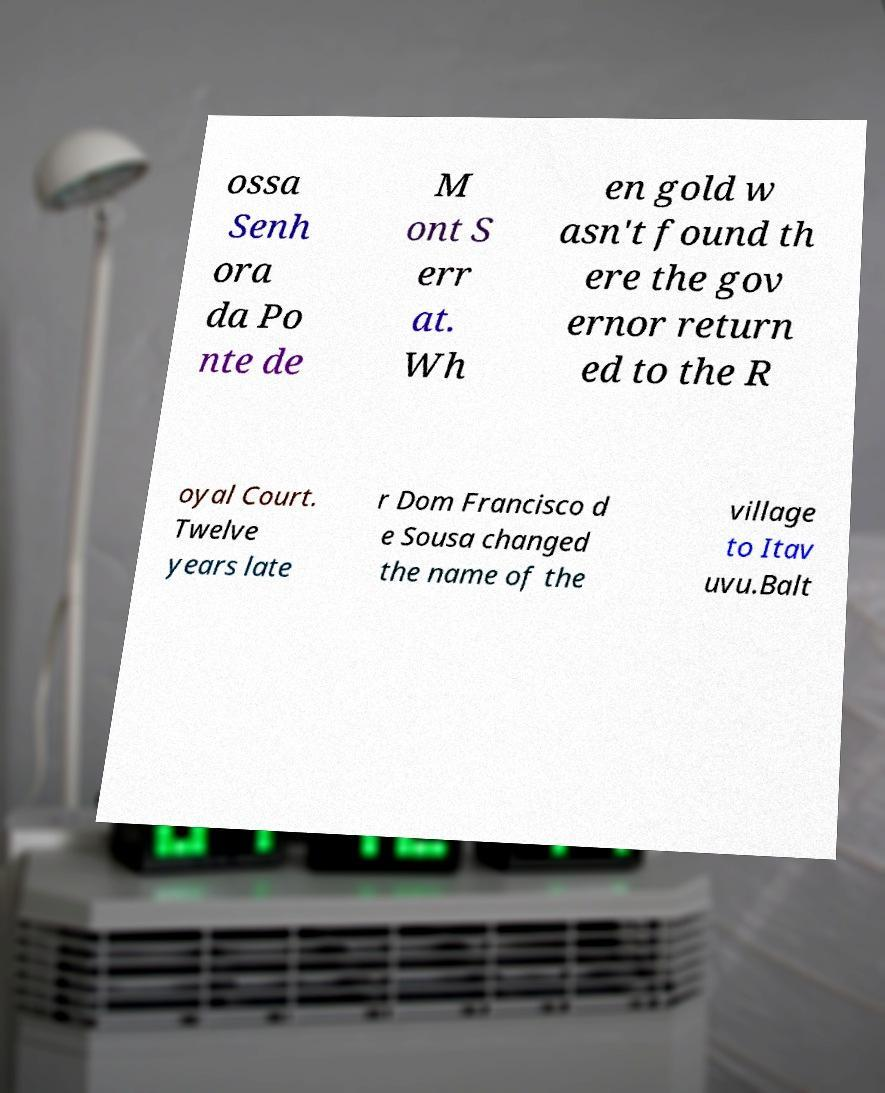Could you assist in decoding the text presented in this image and type it out clearly? ossa Senh ora da Po nte de M ont S err at. Wh en gold w asn't found th ere the gov ernor return ed to the R oyal Court. Twelve years late r Dom Francisco d e Sousa changed the name of the village to Itav uvu.Balt 